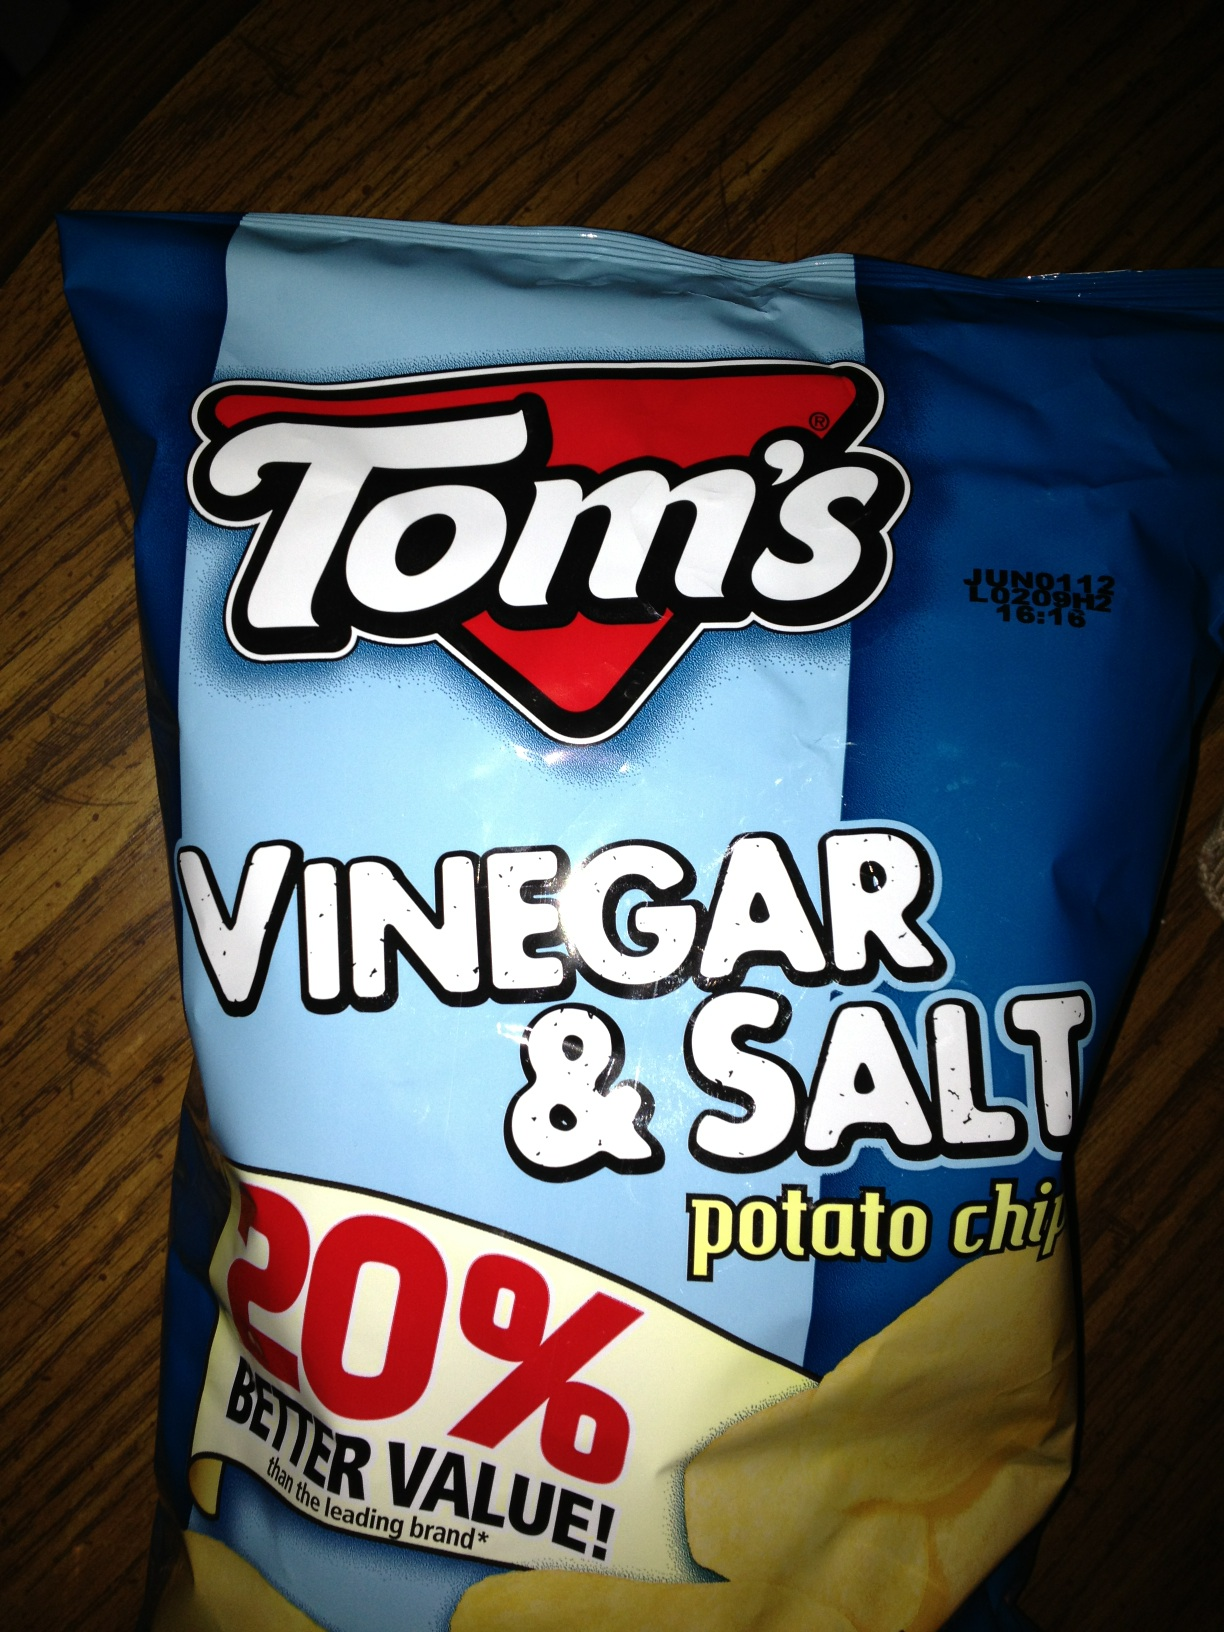What would you pair these chips with for a perfect snack combo? For the perfect snack combo, pair Tom's Vinegar & Salt potato chips with a creamy dip like French onion or ranch to balance out the tartness. Accompany them with a refreshing lemonade or iced tea to complement the tangy flavor, creating a delightful and refreshing snack experience. Can you suggest a creative recipe using these chips? Certainly! Try making a Vinegar & Salt Chip Crusted Fish. Start by crushing a bag of Tom's Vinegar & Salt chips and mixing them with breadcrumbs. Coat fish fillets with flour, dip them in beaten egg, and then press the chip mixture onto the fish. Bake in a preheated oven at 400°F for about 15-20 minutes until golden and crispy. Serve with a side of lemon aioli and a fresh green salad. This recipe gives you a crispy, tangy crust that’s full of flavor. 